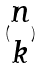<formula> <loc_0><loc_0><loc_500><loc_500>( \begin{matrix} n \\ k \end{matrix} )</formula> 